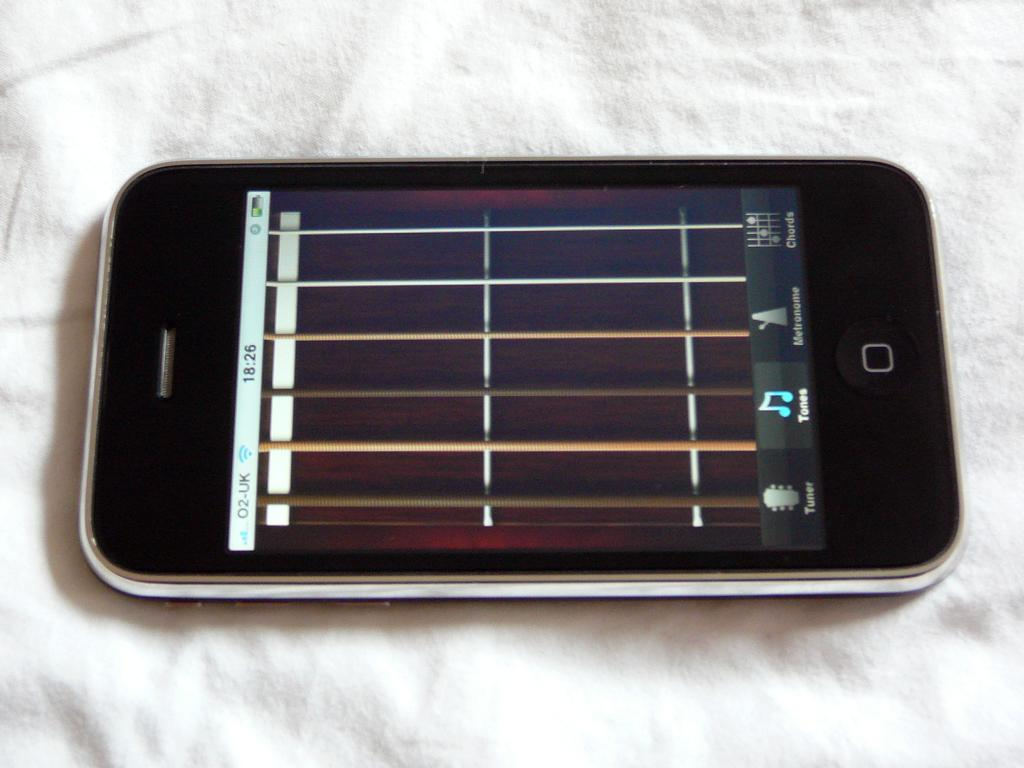<image>
Summarize the visual content of the image. a phone with the service O2-UK open to a screen with a grid pattern 